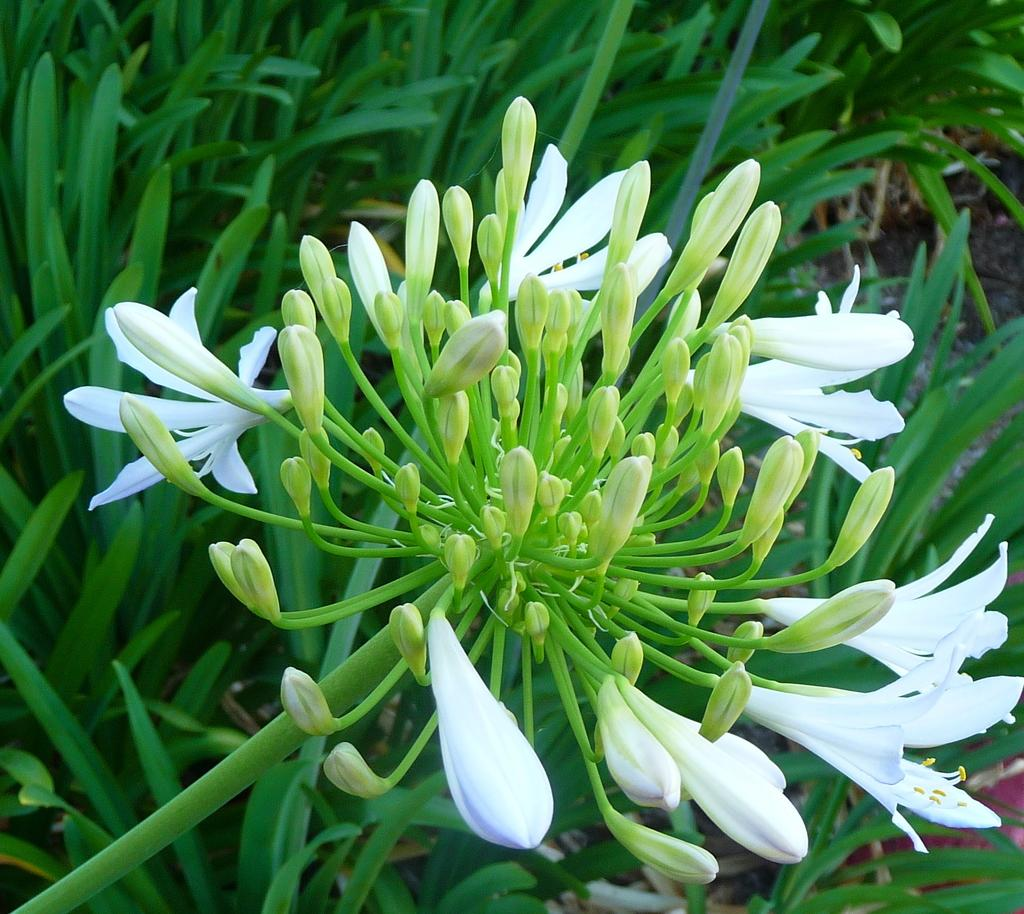What is the main subject of the image? The main subject of the image is a group of flowers. Can you describe the flowers in more detail? Yes, there are flower buds in the image. What colors are the flower buds? Some of the flower buds are white in color, while others are small and light green in color. Can you tell me how many donkeys are grazing among the flowers in the image? There are no donkeys present in the image; it features a group of flowers and flower buds. What type of leaf is shown in the image? The image does not show any leaves; it focuses on the flowers and flower buds. 